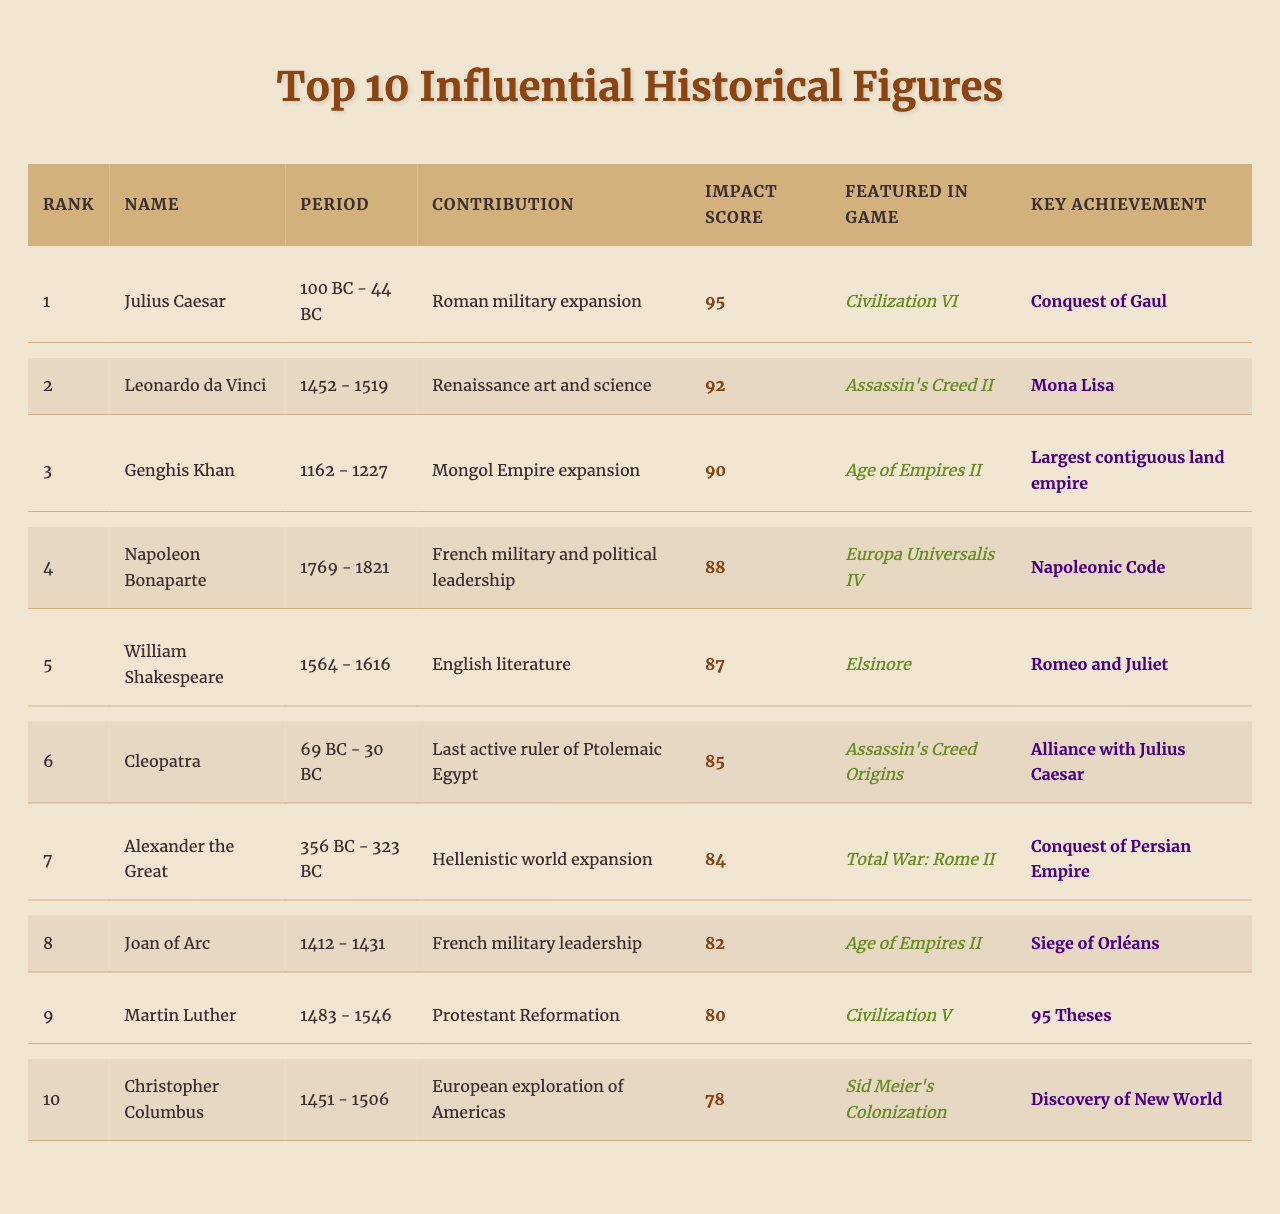What was the contribution of Julius Caesar? The table shows that Julius Caesar's contribution was Roman military expansion.
Answer: Roman military expansion Which historical figure has the highest impact score? According to the table, Julius Caesar has the highest impact score of 95.
Answer: Julius Caesar Is Cleopatra featured in a game? The table indicates that Cleopatra is featured in "Assassin's Creed Origins."
Answer: Yes What was the key achievement of Leonardo da Vinci? The table lists the key achievement of Leonardo da Vinci as the Mona Lisa.
Answer: Mona Lisa How many figures have an impact score above 85? The table lists Julius Caesar, Leonardo da Vinci, Genghis Khan, Napoleon Bonaparte, William Shakespeare, Cleopatra, Alexander the Great, and Joan of Arc, totaling 8 figures with an impact score above 85.
Answer: 8 What is the average impact score of the top 10 historical figures? Adding the impact scores (95 + 92 + 90 + 88 + 87 + 85 + 84 + 82 + 80 + 78 =  906) and dividing by 10 gives an average impact score of 90.6.
Answer: 90.6 Who was the last ruler of Ptolemaic Egypt? The table states that Cleopatra was the last active ruler of Ptolemaic Egypt.
Answer: Cleopatra Which two figures are featured in "Age of Empires II"? According to the table, Genghis Khan and Joan of Arc are both featured in "Age of Empires II."
Answer: Genghis Khan and Joan of Arc What contributions are associated with Martin Luther? The table shows that Martin Luther's contribution is the Protestant Reformation.
Answer: Protestant Reformation Was Napoleon Bonaparte alive during the Renaissance period? The table shows that Napoleon Bonaparte lived from 1769 to 1821, which is after the Renaissance period (14th to 17th century), so he was not alive during that time.
Answer: No What rank is Christopher Columbus? The table indicates that Christopher Columbus is ranked 10th.
Answer: 10th Which historical figure achieved the largest contiguous land empire? The table states that Genghis Khan achieved the largest contiguous land empire.
Answer: Genghis Khan How many figures have their key achievements listed as literary works? The table shows that only William Shakespeare has a key achievement that is a literary work (Romeo and Juliet), thus only 1 figure.
Answer: 1 Who contributed to the expansion of the Mongol Empire? The table indicates that Genghis Khan contributed to the expansion of the Mongol Empire.
Answer: Genghis Khan 